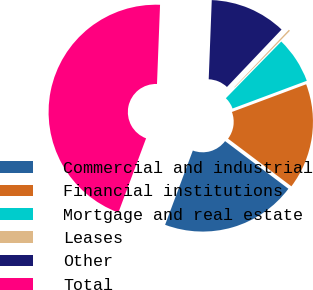Convert chart to OTSL. <chart><loc_0><loc_0><loc_500><loc_500><pie_chart><fcel>Commercial and industrial<fcel>Financial institutions<fcel>Mortgage and real estate<fcel>Leases<fcel>Other<fcel>Total<nl><fcel>20.42%<fcel>15.95%<fcel>7.0%<fcel>0.22%<fcel>11.48%<fcel>44.93%<nl></chart> 